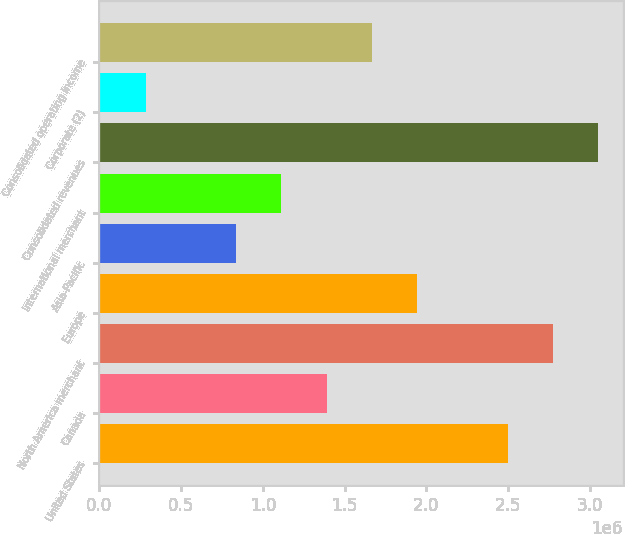Convert chart to OTSL. <chart><loc_0><loc_0><loc_500><loc_500><bar_chart><fcel>United States<fcel>Canada<fcel>North America merchant<fcel>Europe<fcel>Asia-Pacific<fcel>International merchant<fcel>Consolidated revenues<fcel>Corporate (2)<fcel>Consolidated operating income<nl><fcel>2.497e+06<fcel>1.39014e+06<fcel>2.77372e+06<fcel>1.94357e+06<fcel>836715<fcel>1.11343e+06<fcel>3.05043e+06<fcel>283286<fcel>1.66686e+06<nl></chart> 